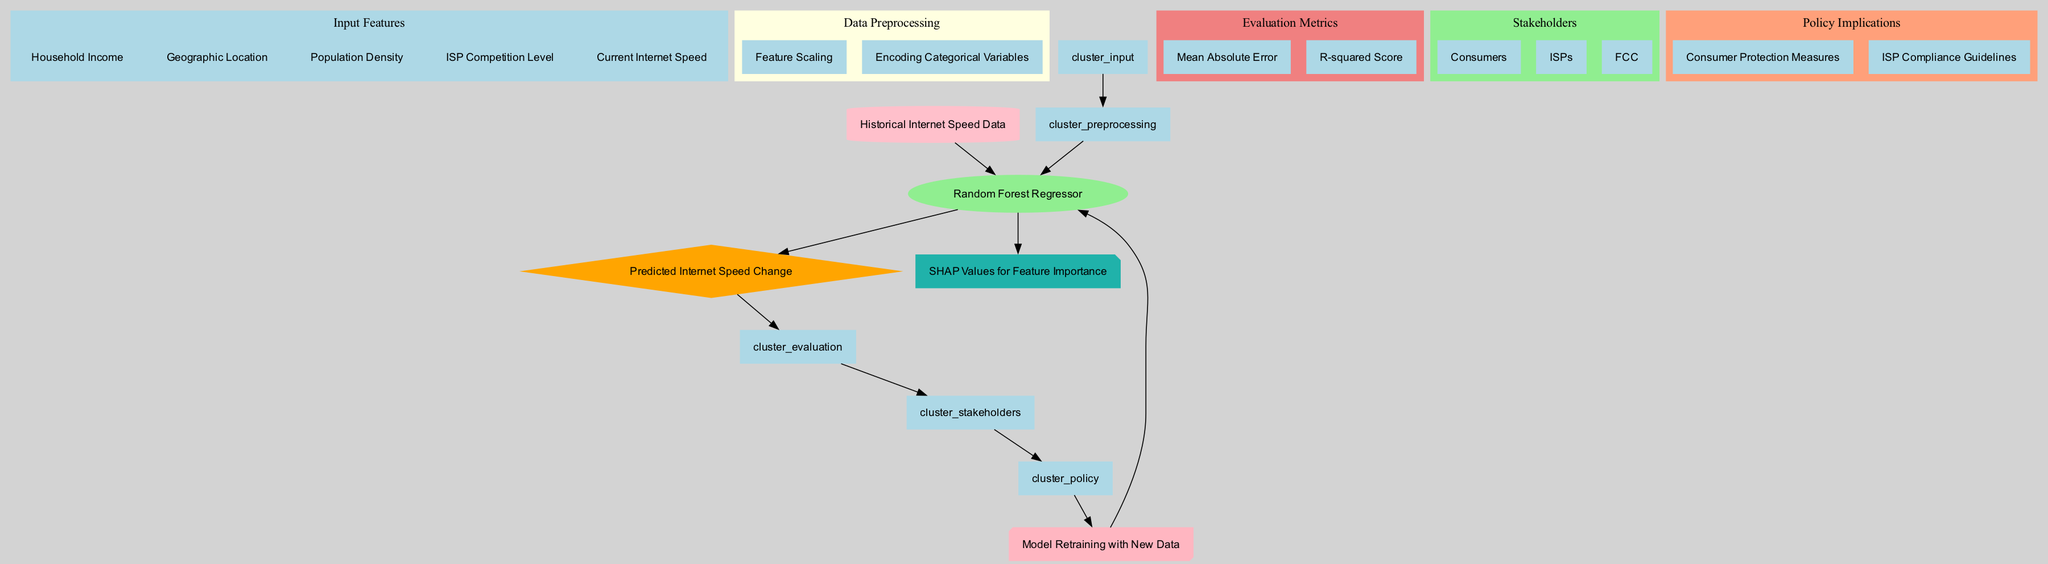What are the input features of the model? The diagram lists five input features: Household Income, Geographic Location, Population Density, ISP Competition Level, and Current Internet Speed. These features are grouped together in the Input Features section of the diagram.
Answer: Household Income, Geographic Location, Population Density, ISP Competition Level, Current Internet Speed Which machine learning model is used? The diagram specifies the model used for predictions as a Random Forest Regressor. This is indicated in the Model section of the diagram.
Answer: Random Forest Regressor What does the model predict? The output prediction of the model, as shown in the diagram, is the Predicted Internet Speed Change. This is clearly indicated as the output from the model.
Answer: Predicted Internet Speed Change How many evaluation metrics are listed in the diagram? The diagram contains two evaluation metrics: Mean Absolute Error and R-squared Score. By counting the metrics in the Evaluation Metrics section, we find there are two.
Answer: 2 What is the purpose of SHAP values in this diagram? SHAP values are used for feature importance interpretability as indicated in the Interpretability section of the diagram. This means SHAP values help understand the influence of each input feature on the model’s predictions.
Answer: Feature Importance Which stakeholders are identified in the diagram? The diagram identifies three stakeholders: Consumers, ISPs, and FCC. These stakeholders are grouped in the Stakeholders section of the diagram.
Answer: Consumers, ISPs, FCC How does the feedback loop work in the model? The feedback loop involves Model Retraining with New Data, as shown in the diagram. This means after predictions are made, as new data comes in, the model is retrained to improve its accuracy based on updated information.
Answer: Model Retraining with New Data What is the relationship between output predictions and evaluation metrics? Output predictions are directly linked to the evaluation metrics; after generating the Predicted Internet Speed Change, the model's performance is assessed using the selected evaluation metrics, which are Mean Absolute Error and R-squared Score.
Answer: Assessment of Performance What are the policy implications derived from the model? The diagram lists two policy implications: Consumer Protection Measures and ISP Compliance Guidelines. These are important results that stakeholders can derive from the model's outcomes.
Answer: Consumer Protection Measures, ISP Compliance Guidelines 